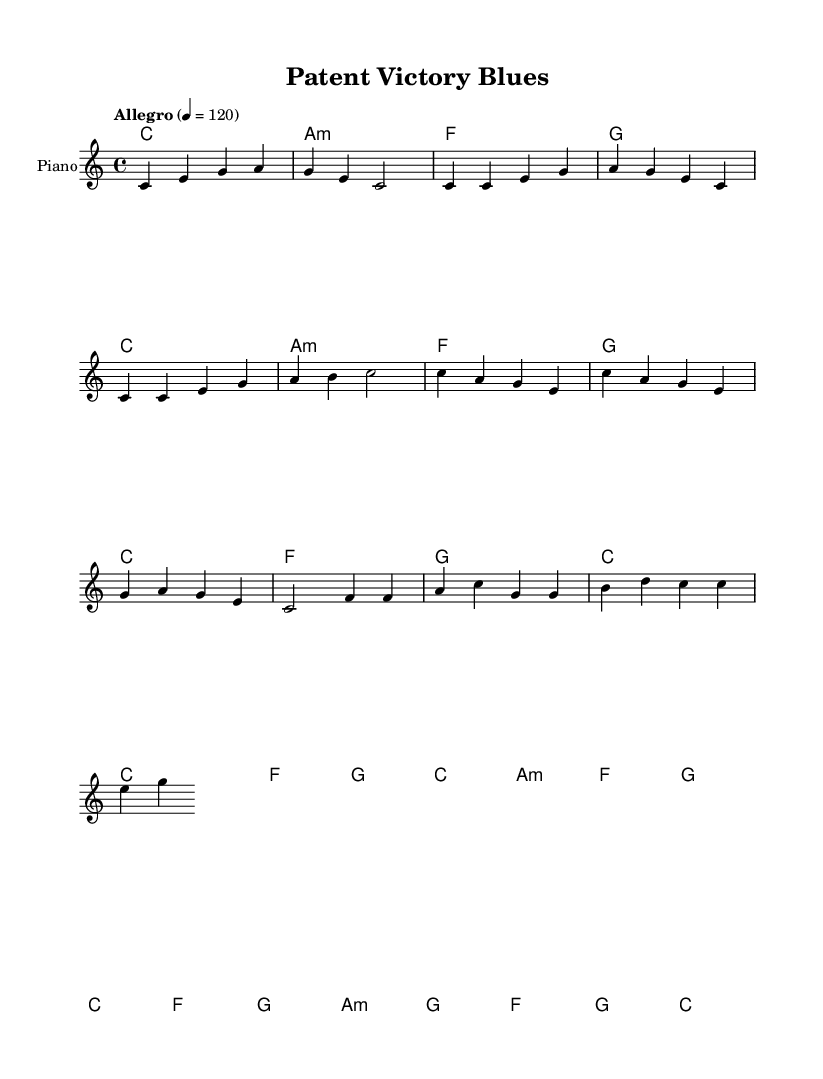What is the key signature of this music? The key signature is C major, which has no sharps or flats indicated in the sheet music.
Answer: C major What is the time signature of this music? The time signature shown in the sheet music is 4/4, indicating there are four beats per measure.
Answer: 4/4 What is the specified tempo of this piece? The tempo is marked as "Allegro" with a metronome marking of 120 beats per minute, indicating a fast pace.
Answer: Allegro 4 = 120 How many measures are in the verse section? The verse section contains four measures, which can be counted from the melody line.
Answer: 4 What chords are used in the chorus? The chords in the chorus are C, F, G, and A minor, based on the harmonic progression provided in the sheet music.
Answer: C, F, G, A minor What is the relationship between the melody and harmony during the bridge? During the bridge, the melody uses notes from the chords F, G, and A minor, demonstrating a typical R&B harmonic structure with a shifting focus to build tension.
Answer: F, G, A minor What thematic elements are conveyed in the verse lyrics? The verse lyrics reflect a struggle through legal challenges and perseverance, common themes in R&B that resonate with overcoming obstacles.
Answer: Legal struggle and perseverance 